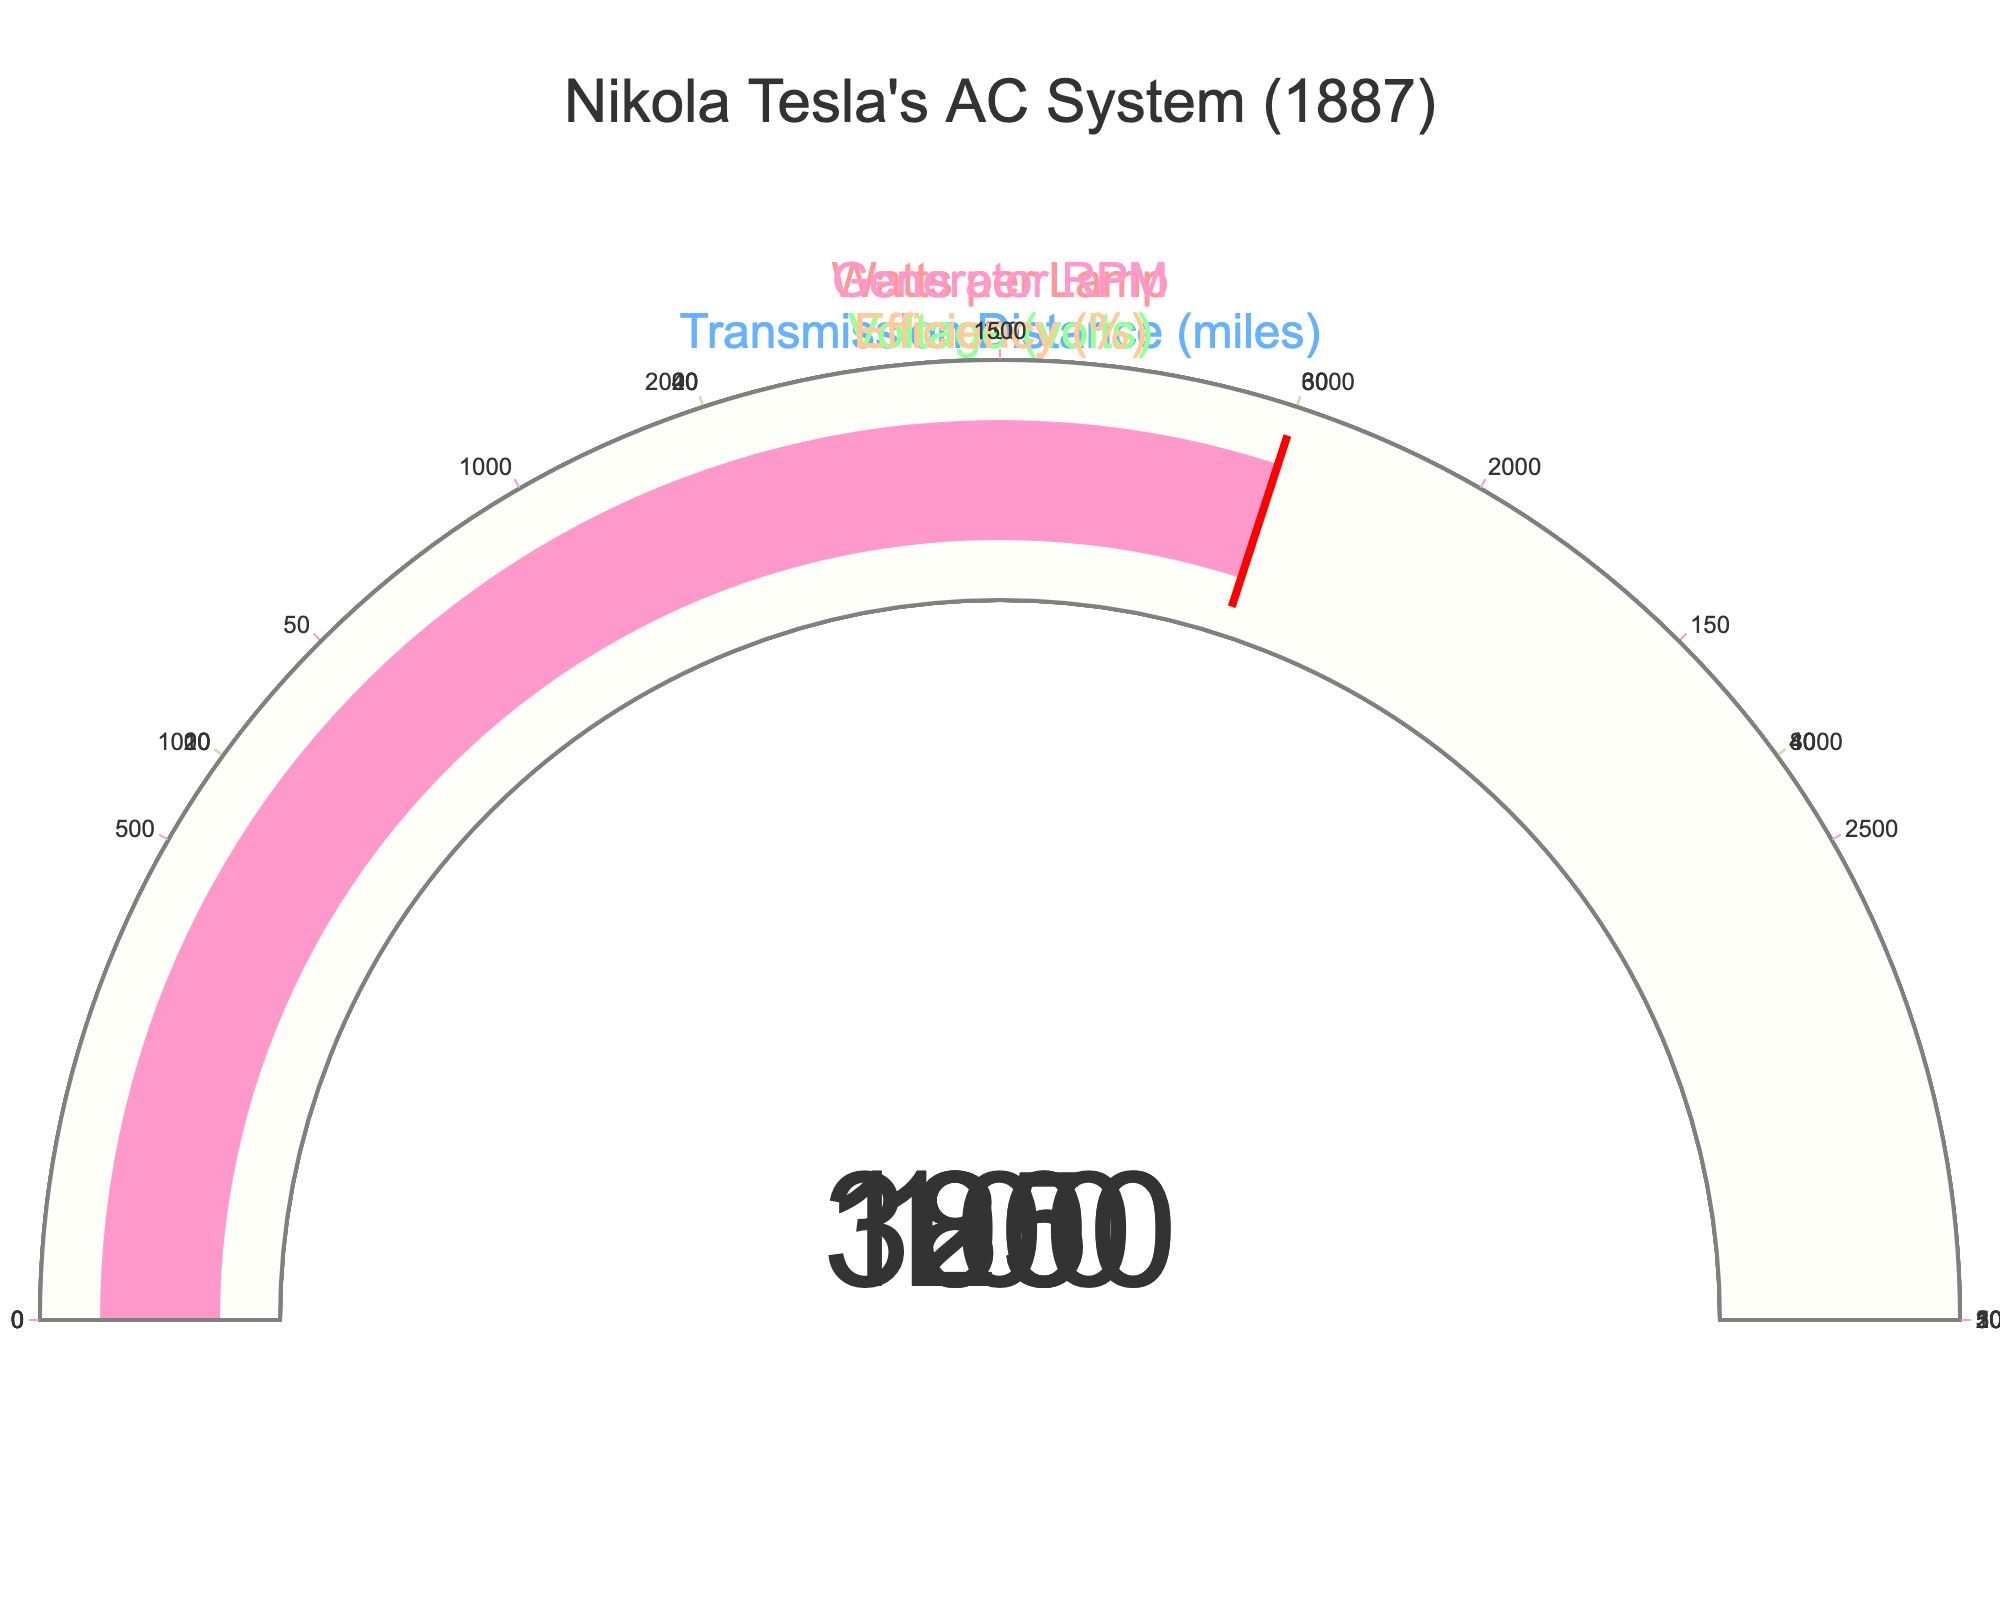what are the values depicted by gauges in Tesla's AC system figure? The figure shows several gauges, each indicating specific values for Tesla's AC system parameters in 1887. These are: Watts per Lamp (100), Transmission Distance (25), Voltage (3000), Efficiency (85), and Generator RPM (1800).
Answer: 100, 25, 3000, 85, 1800 What is the highest MaxValue among the parameters shown? By inspecting the maximum values on each gauge, we see that the highest MaxValue is 5000 volts for the Voltage parameter.
Answer: 5000 volts What percentage of the MaxValue is the Efficiency gauge showing? The Efficiency gauge shows a value of 85, and its MaxValue is 100. Calculating the percentage: (85/100) * 100 = 85%.
Answer: 85% How does the Transmission Distance compare to its MaxValue? The Transmission Distance gauge shows a value of 25 miles, and the MaxValue is 50 miles. Therefore, the Transmission Distance is 50% of its MaxValue.
Answer: 50% What is the difference between the Voltage and the Generator RPM values? The Voltage gauge indicates 3000 volts, and the Generator RPM gauge shows 1800 RPM. The difference between these values is 3000 - 1800 = 1200.
Answer: 1200 Which parameter has the smallest value relative to its MaxValue? Comparing the relative values: Watts per Lamp (100/200 = 0.5), Transmission Distance (25/50 = 0.5), Voltage (3000/5000 = 0.6), Efficiency (85/100 = 0.85), Generator RPM (1800/3000 = 0.6). Both Watts per Lamp and Transmission Distance have the smallest relative value of 0.5 or 50%.
Answer: Watts per Lamp and Transmission Distance What is the average value of all parameters displayed in the figure? The values displayed are 100, 25, 3000, 85, and 1800. Adding them gives 4010. There are 5 parameters, so the average value is 4010 / 5 = 802.
Answer: 802 